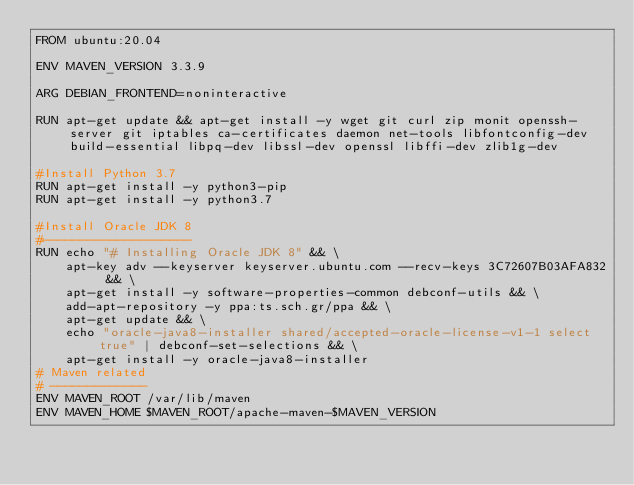<code> <loc_0><loc_0><loc_500><loc_500><_Dockerfile_>FROM ubuntu:20.04

ENV MAVEN_VERSION 3.3.9

ARG DEBIAN_FRONTEND=noninteractive

RUN apt-get update && apt-get install -y wget git curl zip monit openssh-server git iptables ca-certificates daemon net-tools libfontconfig-dev build-essential libpq-dev libssl-dev openssl libffi-dev zlib1g-dev

#Install Python 3.7
RUN apt-get install -y python3-pip
RUN apt-get install -y python3.7

#Install Oracle JDK 8
#--------------------
RUN echo "# Installing Oracle JDK 8" && \
    apt-key adv --keyserver keyserver.ubuntu.com --recv-keys 3C72607B03AFA832 && \
    apt-get install -y software-properties-common debconf-utils && \
    add-apt-repository -y ppa:ts.sch.gr/ppa && \
    apt-get update && \
    echo "oracle-java8-installer shared/accepted-oracle-license-v1-1 select true" | debconf-set-selections && \
    apt-get install -y oracle-java8-installer
# Maven related
# -------------
ENV MAVEN_ROOT /var/lib/maven
ENV MAVEN_HOME $MAVEN_ROOT/apache-maven-$MAVEN_VERSION</code> 